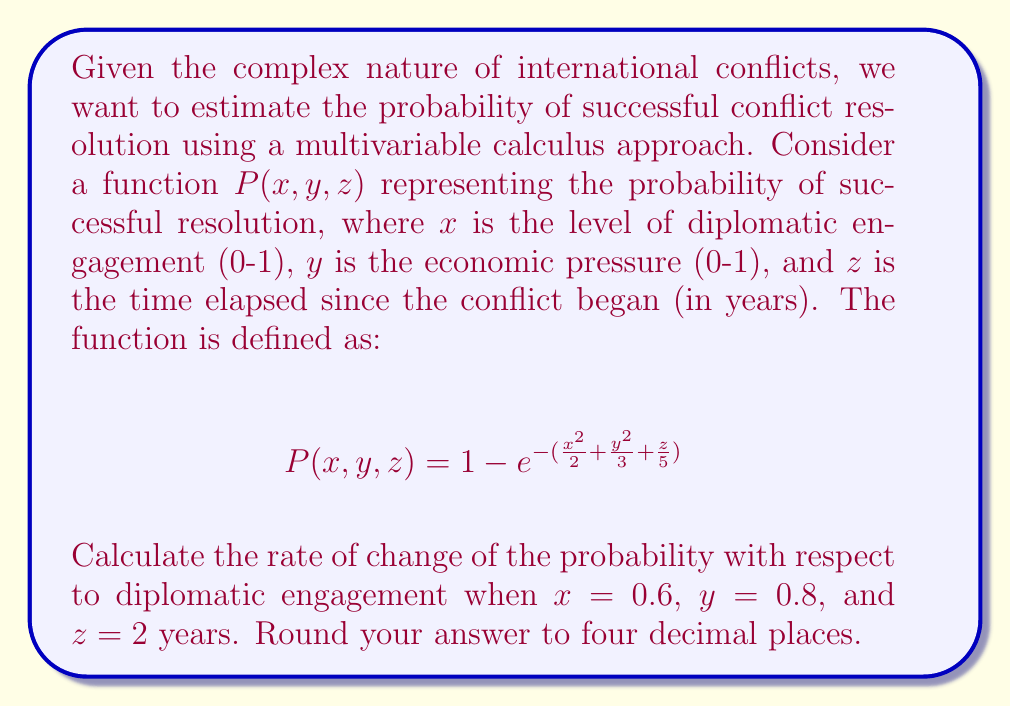Help me with this question. To solve this problem, we need to follow these steps:

1) First, we need to find the partial derivative of $P$ with respect to $x$:

   $$\frac{\partial P}{\partial x} = e^{-(\frac{x^2}{2} + \frac{y^2}{3} + \frac{z}{5})} \cdot x$$

2) Now, we need to evaluate this partial derivative at the given points:
   $x = 0.6$, $y = 0.8$, and $z = 2$

3) Let's calculate the exponent first:
   $$\frac{x^2}{2} + \frac{y^2}{3} + \frac{z}{5} = \frac{(0.6)^2}{2} + \frac{(0.8)^2}{3} + \frac{2}{5}$$
   $$= 0.18 + 0.2133... + 0.4 = 0.7933...$$

4) Now we can evaluate the partial derivative:

   $$\frac{\partial P}{\partial x} |_{(0.6, 0.8, 2)} = e^{-0.7933...} \cdot 0.6$$

5) Calculate this value:
   $$= 0.4523... \cdot 0.6 = 0.2714...$$

6) Rounding to four decimal places:
   $$= 0.2714$$

This result represents the rate of change of the probability of successful conflict resolution with respect to diplomatic engagement, given the specified levels of economic pressure and time elapsed.
Answer: $0.2714$ 